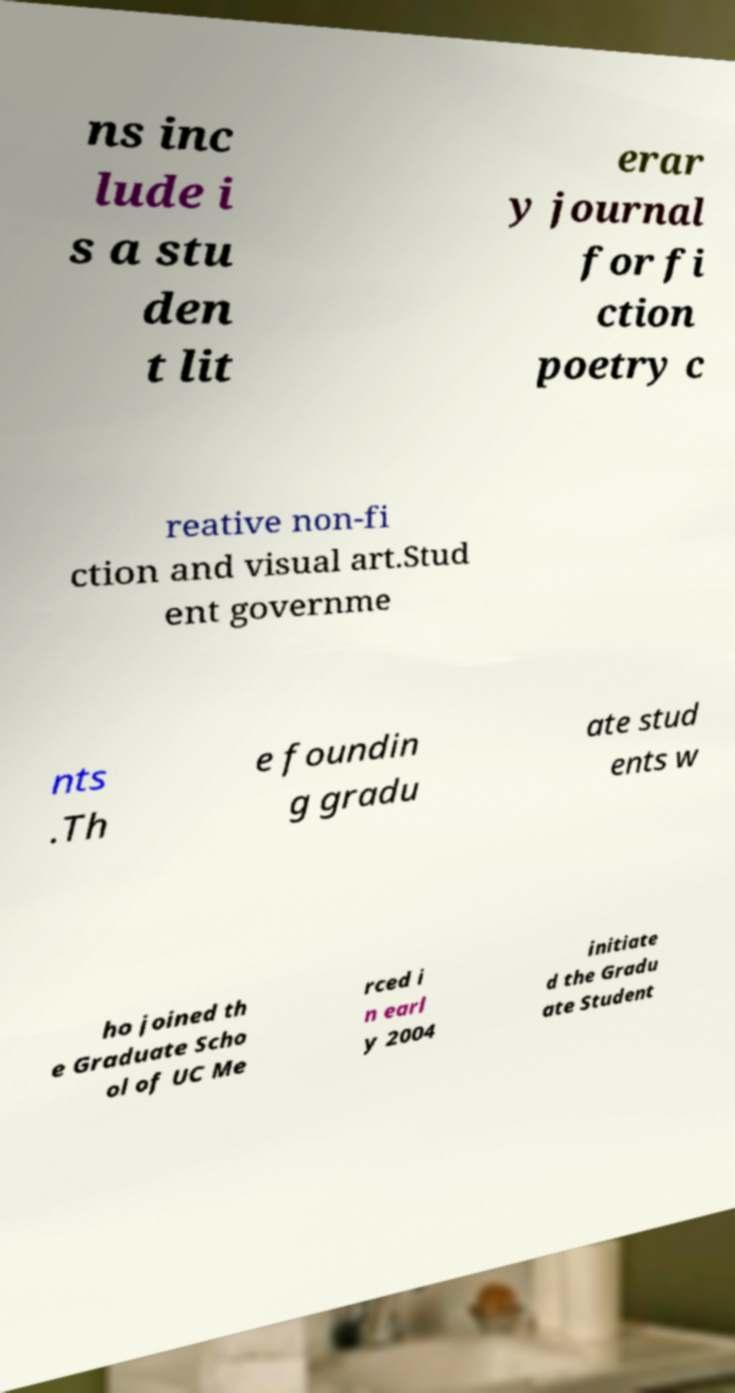Could you extract and type out the text from this image? ns inc lude i s a stu den t lit erar y journal for fi ction poetry c reative non-fi ction and visual art.Stud ent governme nts .Th e foundin g gradu ate stud ents w ho joined th e Graduate Scho ol of UC Me rced i n earl y 2004 initiate d the Gradu ate Student 